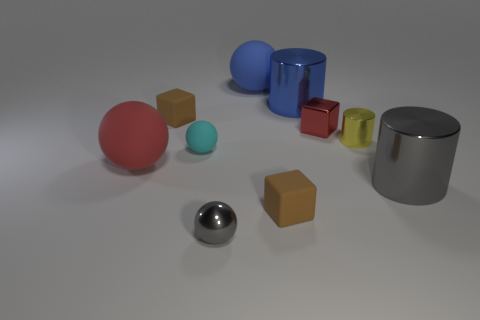There is a metallic cylinder that is the same color as the metal ball; what is its size?
Offer a terse response. Large. There is a gray cylinder that is the same material as the small yellow object; what is its size?
Offer a terse response. Large. What number of yellow objects are matte objects or tiny metallic balls?
Provide a succinct answer. 0. The rubber object that is the same color as the small metallic cube is what shape?
Your answer should be compact. Sphere. Is there anything else that has the same material as the red sphere?
Give a very brief answer. Yes. There is a small metallic thing in front of the big red rubber thing; is it the same shape as the rubber object in front of the large gray metallic cylinder?
Offer a very short reply. No. How many cyan metal cylinders are there?
Offer a terse response. 0. The small gray object that is the same material as the yellow cylinder is what shape?
Your response must be concise. Sphere. Is there anything else that has the same color as the small metal cylinder?
Keep it short and to the point. No. There is a tiny metal cylinder; is its color the same as the large ball that is in front of the cyan thing?
Your answer should be compact. No. 